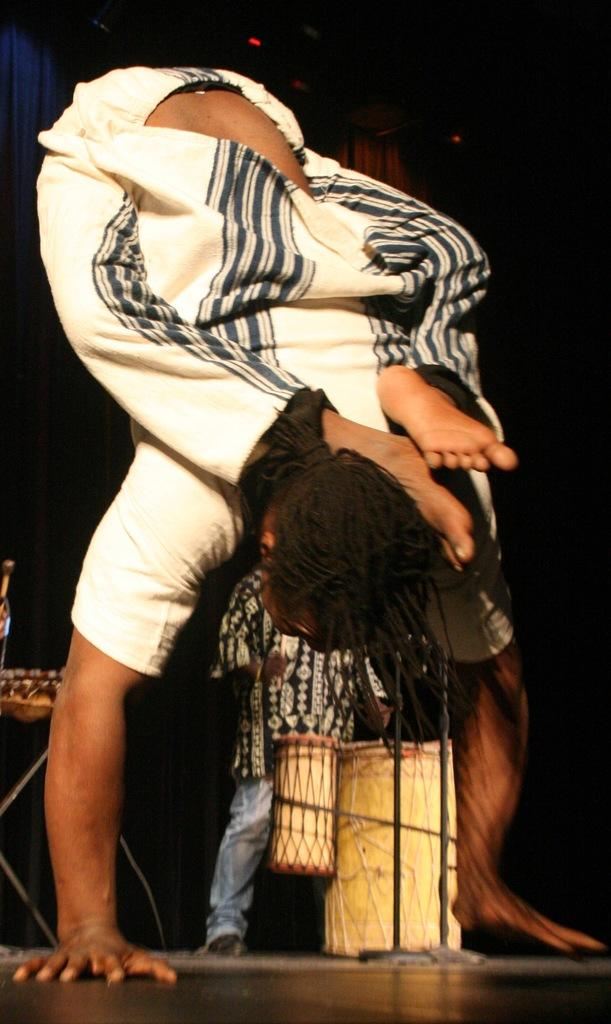How many people are in the image? There are two persons in the image. Where are the persons located in the image? The persons are on the floor. What can be seen in the background of the image? There are musical instruments in the background of the image. What is the color of the background in the image? The background of the image is dark. What type of business is being conducted in the wilderness in the image? There is no business or wilderness present in the image; it features two persons on the floor with musical instruments in the background. Is there any indication of an attack happening in the image? There is no indication of an attack in the image; it shows a peaceful scene with two persons and musical instruments. 